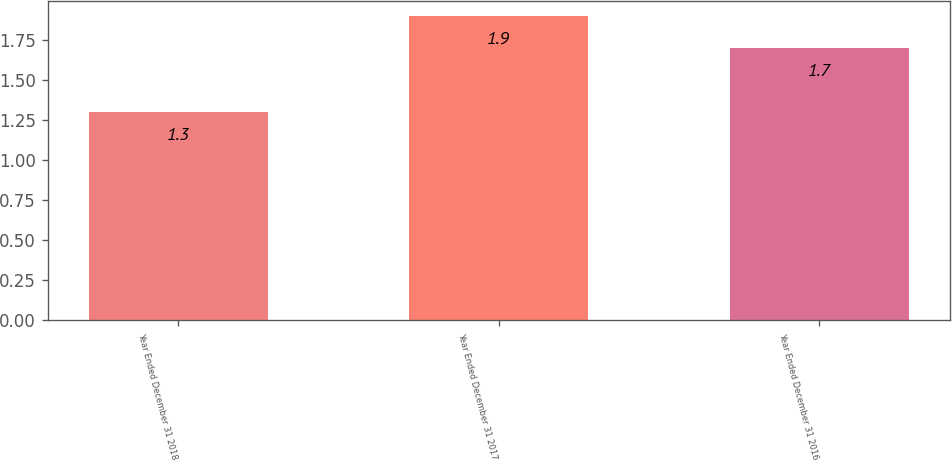<chart> <loc_0><loc_0><loc_500><loc_500><bar_chart><fcel>Year Ended December 31 2018<fcel>Year Ended December 31 2017<fcel>Year Ended December 31 2016<nl><fcel>1.3<fcel>1.9<fcel>1.7<nl></chart> 